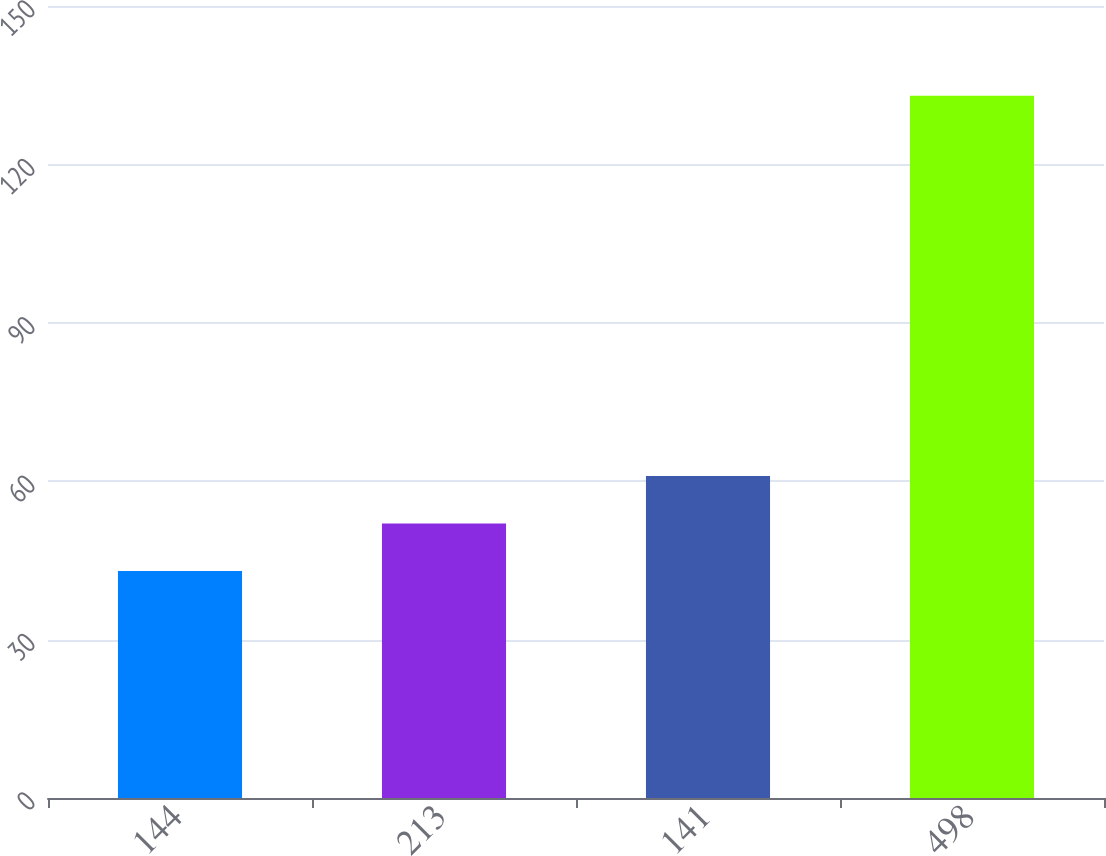<chart> <loc_0><loc_0><loc_500><loc_500><bar_chart><fcel>144<fcel>213<fcel>141<fcel>498<nl><fcel>43<fcel>52<fcel>61<fcel>133<nl></chart> 